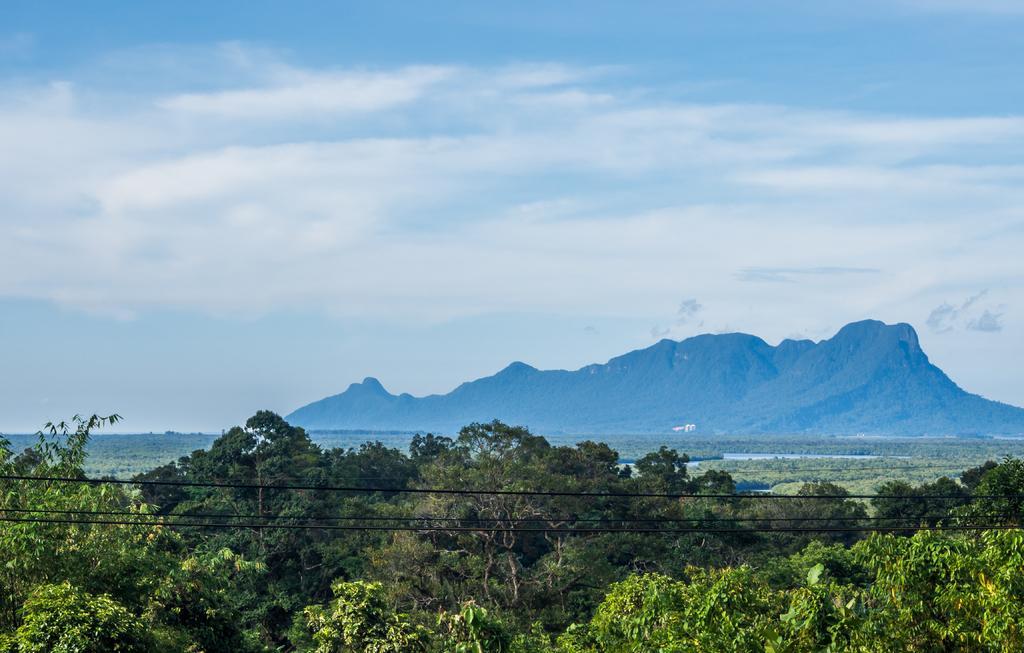Could you give a brief overview of what you see in this image? We can see wires and trees. On the background we can see hill and sky with clouds. 